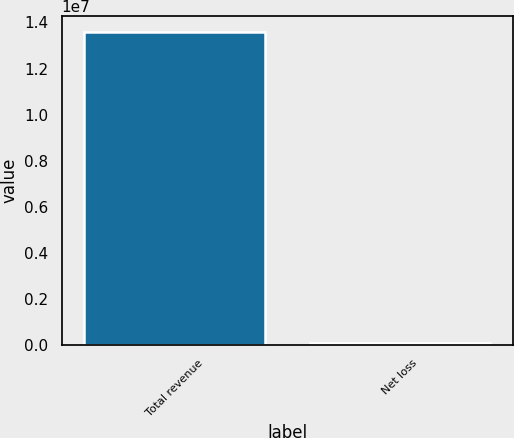<chart> <loc_0><loc_0><loc_500><loc_500><bar_chart><fcel>Total revenue<fcel>Net loss<nl><fcel>1.36e+07<fcel>65000<nl></chart> 